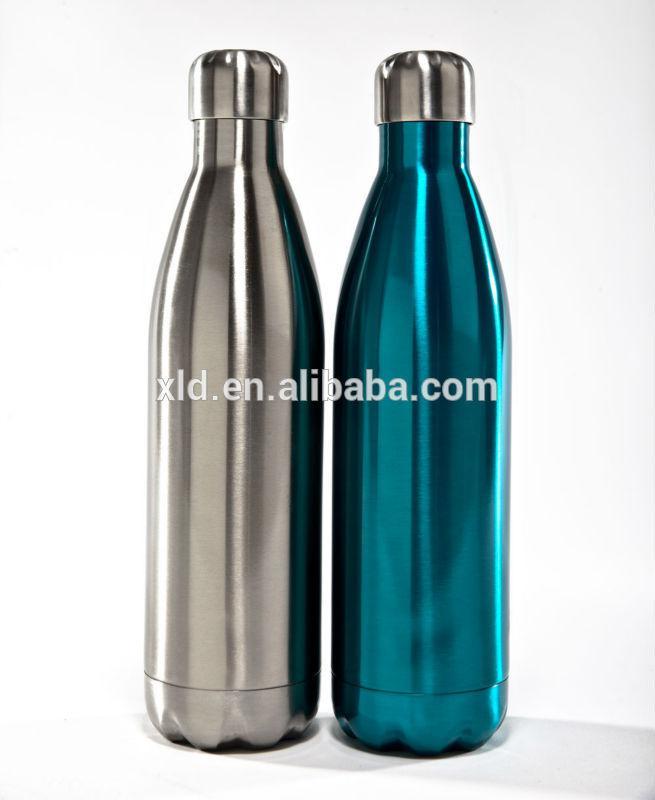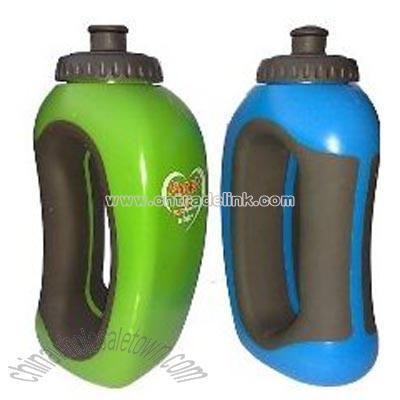The first image is the image on the left, the second image is the image on the right. Examine the images to the left and right. Is the description "The right and left images contain the same number of water bottles." accurate? Answer yes or no. Yes. The first image is the image on the left, the second image is the image on the right. Considering the images on both sides, is "At least one of the containers is green in color." valid? Answer yes or no. Yes. 